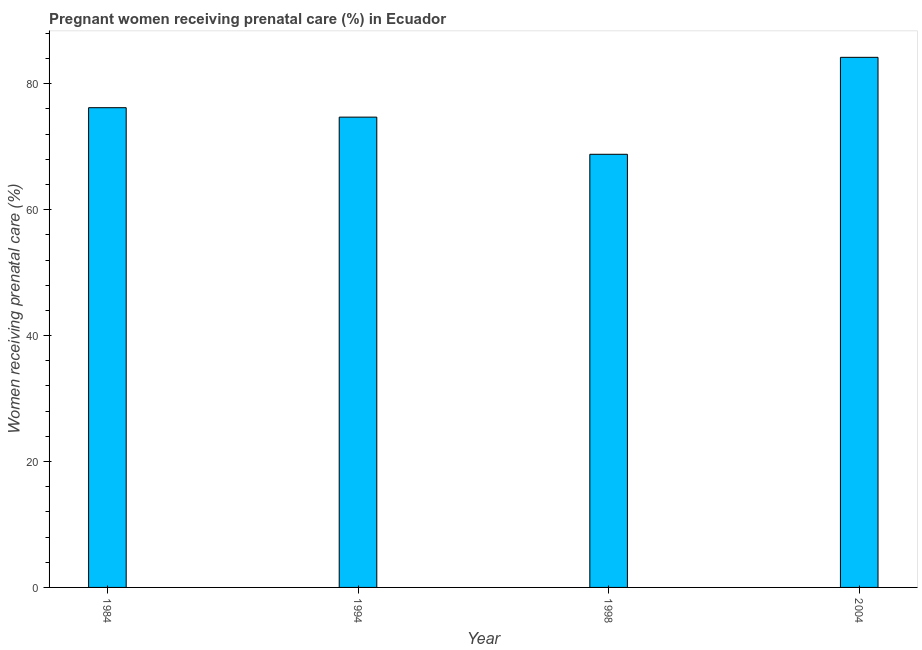Does the graph contain any zero values?
Give a very brief answer. No. Does the graph contain grids?
Provide a succinct answer. No. What is the title of the graph?
Provide a short and direct response. Pregnant women receiving prenatal care (%) in Ecuador. What is the label or title of the Y-axis?
Keep it short and to the point. Women receiving prenatal care (%). What is the percentage of pregnant women receiving prenatal care in 1994?
Provide a succinct answer. 74.7. Across all years, what is the maximum percentage of pregnant women receiving prenatal care?
Your answer should be compact. 84.2. Across all years, what is the minimum percentage of pregnant women receiving prenatal care?
Your response must be concise. 68.8. What is the sum of the percentage of pregnant women receiving prenatal care?
Your answer should be compact. 303.9. What is the average percentage of pregnant women receiving prenatal care per year?
Offer a very short reply. 75.97. What is the median percentage of pregnant women receiving prenatal care?
Ensure brevity in your answer.  75.45. Do a majority of the years between 1998 and 1994 (inclusive) have percentage of pregnant women receiving prenatal care greater than 32 %?
Provide a short and direct response. No. What is the ratio of the percentage of pregnant women receiving prenatal care in 1984 to that in 1994?
Your answer should be very brief. 1.02. Is the percentage of pregnant women receiving prenatal care in 1984 less than that in 1994?
Make the answer very short. No. What is the difference between the highest and the second highest percentage of pregnant women receiving prenatal care?
Your answer should be compact. 8. Is the sum of the percentage of pregnant women receiving prenatal care in 1984 and 2004 greater than the maximum percentage of pregnant women receiving prenatal care across all years?
Provide a succinct answer. Yes. What is the difference between the highest and the lowest percentage of pregnant women receiving prenatal care?
Provide a short and direct response. 15.4. In how many years, is the percentage of pregnant women receiving prenatal care greater than the average percentage of pregnant women receiving prenatal care taken over all years?
Offer a terse response. 2. How many bars are there?
Ensure brevity in your answer.  4. Are all the bars in the graph horizontal?
Provide a succinct answer. No. How many years are there in the graph?
Your answer should be compact. 4. What is the difference between two consecutive major ticks on the Y-axis?
Provide a succinct answer. 20. What is the Women receiving prenatal care (%) of 1984?
Offer a very short reply. 76.2. What is the Women receiving prenatal care (%) in 1994?
Offer a very short reply. 74.7. What is the Women receiving prenatal care (%) in 1998?
Provide a short and direct response. 68.8. What is the Women receiving prenatal care (%) of 2004?
Give a very brief answer. 84.2. What is the difference between the Women receiving prenatal care (%) in 1984 and 1994?
Ensure brevity in your answer.  1.5. What is the difference between the Women receiving prenatal care (%) in 1984 and 2004?
Your answer should be compact. -8. What is the difference between the Women receiving prenatal care (%) in 1994 and 1998?
Provide a short and direct response. 5.9. What is the difference between the Women receiving prenatal care (%) in 1994 and 2004?
Offer a very short reply. -9.5. What is the difference between the Women receiving prenatal care (%) in 1998 and 2004?
Give a very brief answer. -15.4. What is the ratio of the Women receiving prenatal care (%) in 1984 to that in 1998?
Your answer should be very brief. 1.11. What is the ratio of the Women receiving prenatal care (%) in 1984 to that in 2004?
Your response must be concise. 0.91. What is the ratio of the Women receiving prenatal care (%) in 1994 to that in 1998?
Offer a very short reply. 1.09. What is the ratio of the Women receiving prenatal care (%) in 1994 to that in 2004?
Keep it short and to the point. 0.89. What is the ratio of the Women receiving prenatal care (%) in 1998 to that in 2004?
Your response must be concise. 0.82. 